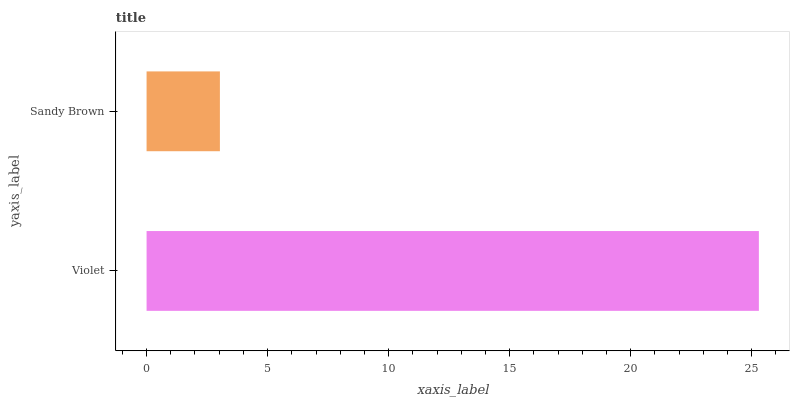Is Sandy Brown the minimum?
Answer yes or no. Yes. Is Violet the maximum?
Answer yes or no. Yes. Is Sandy Brown the maximum?
Answer yes or no. No. Is Violet greater than Sandy Brown?
Answer yes or no. Yes. Is Sandy Brown less than Violet?
Answer yes or no. Yes. Is Sandy Brown greater than Violet?
Answer yes or no. No. Is Violet less than Sandy Brown?
Answer yes or no. No. Is Violet the high median?
Answer yes or no. Yes. Is Sandy Brown the low median?
Answer yes or no. Yes. Is Sandy Brown the high median?
Answer yes or no. No. Is Violet the low median?
Answer yes or no. No. 